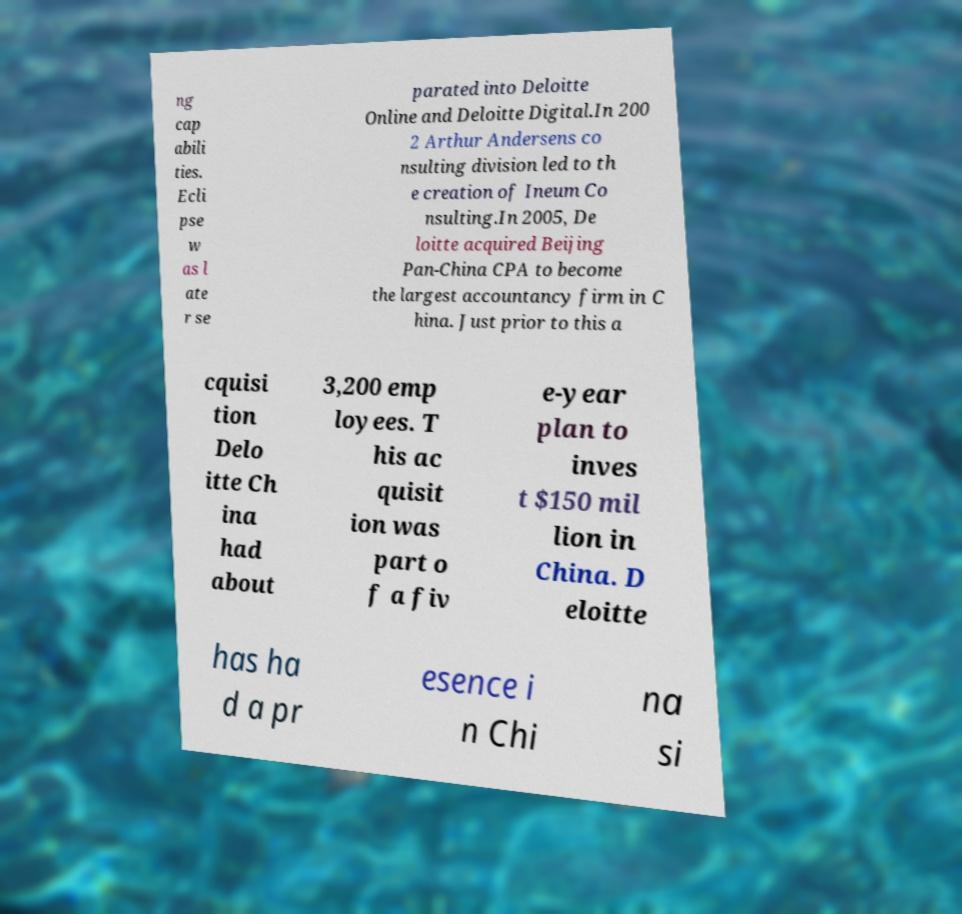Could you extract and type out the text from this image? ng cap abili ties. Ecli pse w as l ate r se parated into Deloitte Online and Deloitte Digital.In 200 2 Arthur Andersens co nsulting division led to th e creation of Ineum Co nsulting.In 2005, De loitte acquired Beijing Pan-China CPA to become the largest accountancy firm in C hina. Just prior to this a cquisi tion Delo itte Ch ina had about 3,200 emp loyees. T his ac quisit ion was part o f a fiv e-year plan to inves t $150 mil lion in China. D eloitte has ha d a pr esence i n Chi na si 